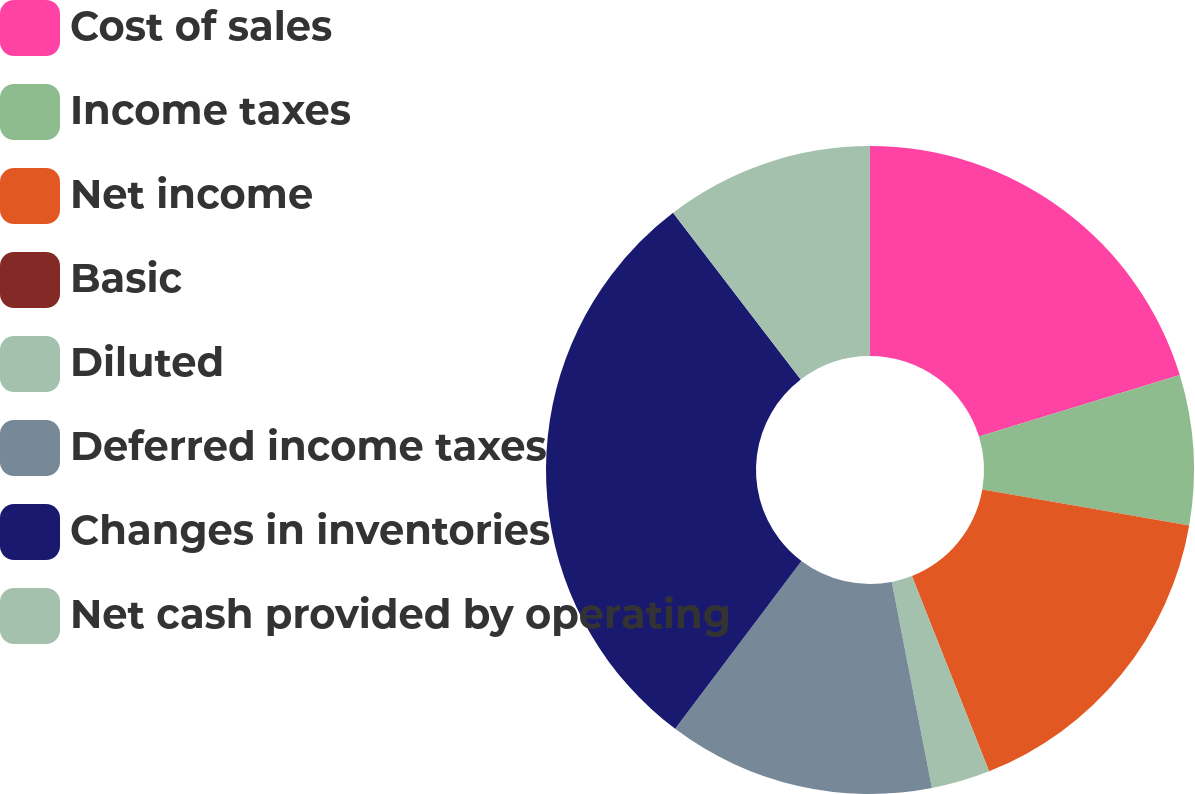Convert chart. <chart><loc_0><loc_0><loc_500><loc_500><pie_chart><fcel>Cost of sales<fcel>Income taxes<fcel>Net income<fcel>Basic<fcel>Diluted<fcel>Deferred income taxes<fcel>Changes in inventories<fcel>Net cash provided by operating<nl><fcel>20.27%<fcel>7.47%<fcel>16.27%<fcel>0.0%<fcel>2.93%<fcel>13.33%<fcel>29.33%<fcel>10.4%<nl></chart> 